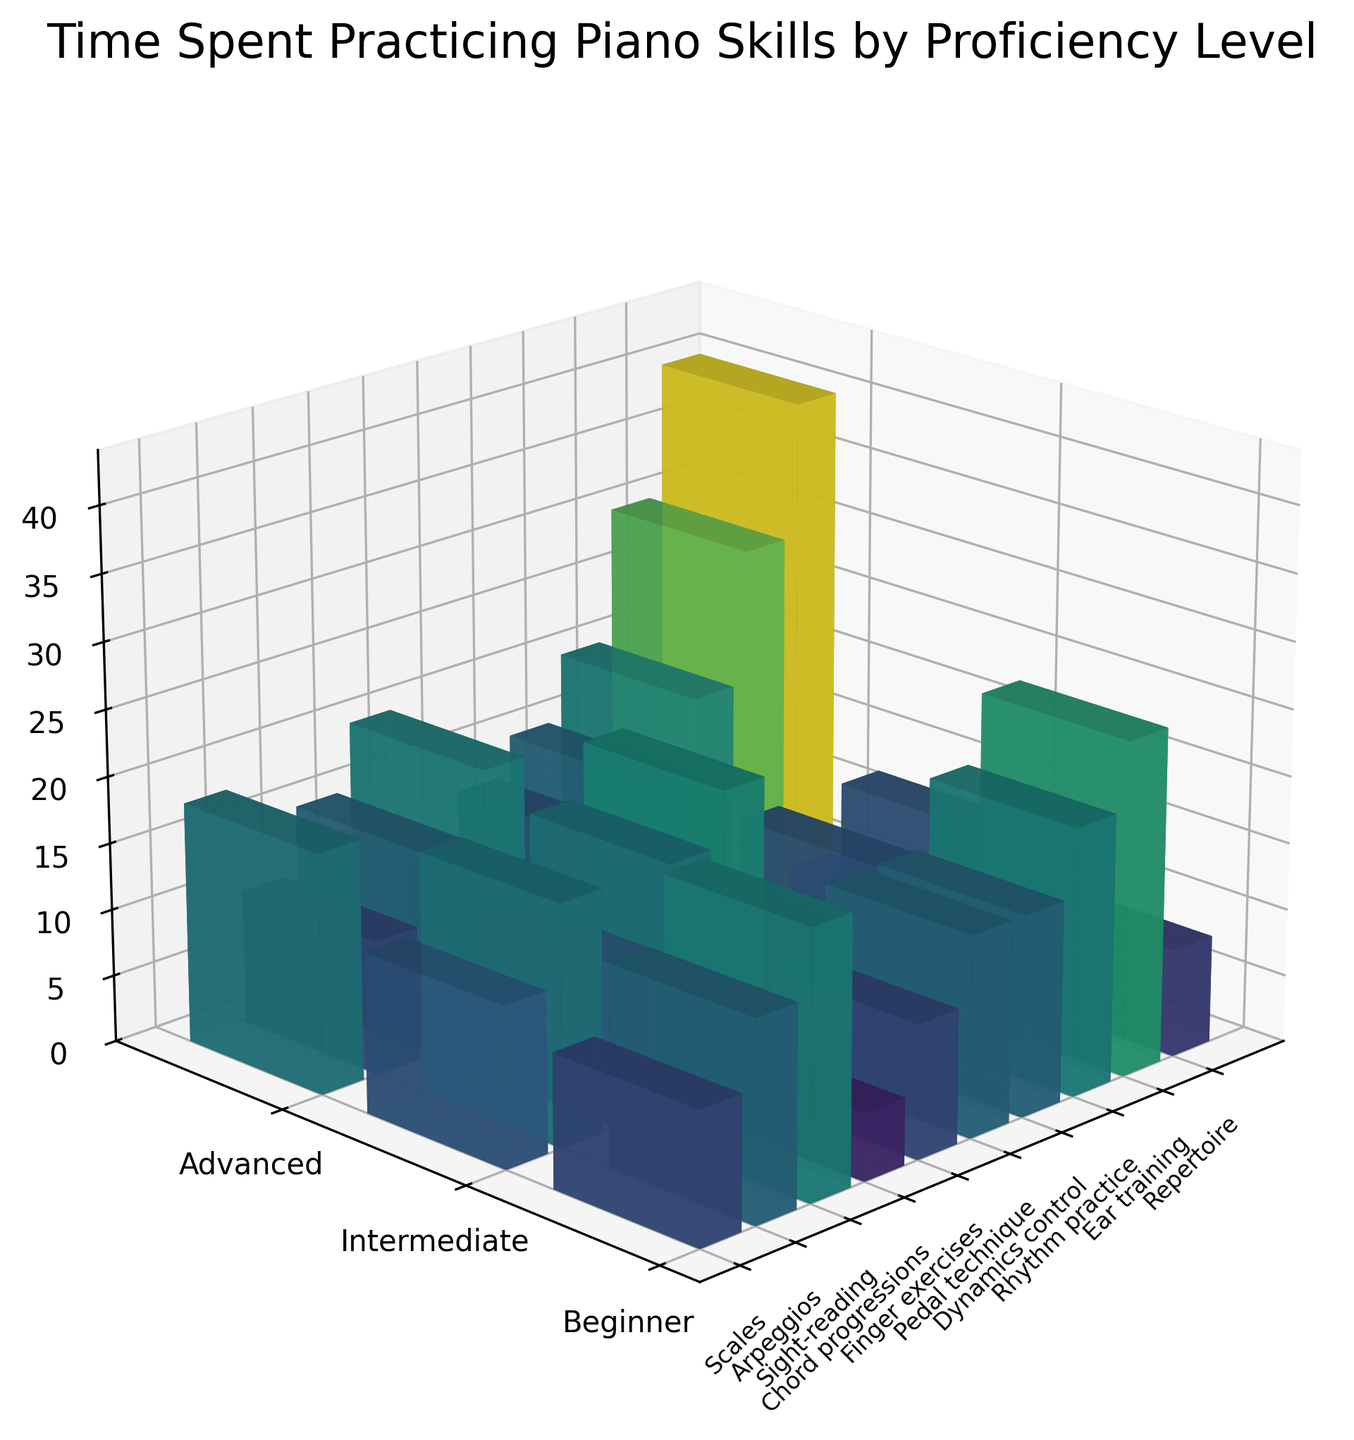What's the title of the plot? The title is typically displayed at the top of the plot and provides an overview of what the figure represents.
Answer: Time Spent Practicing Piano Skills by Proficiency Level What does the 'z' axis represent in the plot? The 'z' axis is labeled with the type of data it represents, which is usually written along the axis itself.
Answer: Time Spent (hours) Which proficiency level spends the most time on Repertoire? To find this, look at the height of the bars corresponding to Repertoire across the different proficiency levels.
Answer: Advanced What is the average time spent on Dynamics control across all proficiency levels? Sum the time spent by Beginners, Intermediates, and Advanced students on Dynamics control (7 + 12 + 18) and divide by 3.
Answer: 12.33 hours How much more time do Intermediate students spend on Scales compared to Beginner students? Subtract the time Beginner students spent on Scales from that of Intermediate students (15 - 10).
Answer: 5 hours Which skill has the largest difference in practice time between Beginner and Advanced students? Calculate the differences in hours for each skill and identify the maximum. For example, Repertoire has the largest difference: 40 - 20 = 20 hours.
Answer: Repertoire In which skill do Advanced students spend twice as much time as Beginner students? Compare each skill's practice times and find where the Advanced time is twice the Beginner time. For Finger exercises: 22 is roughly twice 12.
Answer: Finger exercises How does the time spent on Arpeggios compare across proficiency levels? Observe the height of the bars for Arpeggios for each proficiency level: 5 hours for Beginner, 10 hours for Intermediate, and 15 hours for Advanced.
Answer: Increases What is the total time Advanced students spend on all skills combined? Sum the time spent by Advanced students on all skills: 20 + 15 + 25 + 18 + 22 + 12 + 18 + 20 + 15 + 40.
Answer: 205 hours Which skill has equal practice time among Beginner and Intermediate students? Compare the heights of bars for skills for Beginner and Intermediate students, look for equal heights. For Rhythm practice: both Beginner and Intermediate bars are 15 hours.
Answer: Rhythm practice 